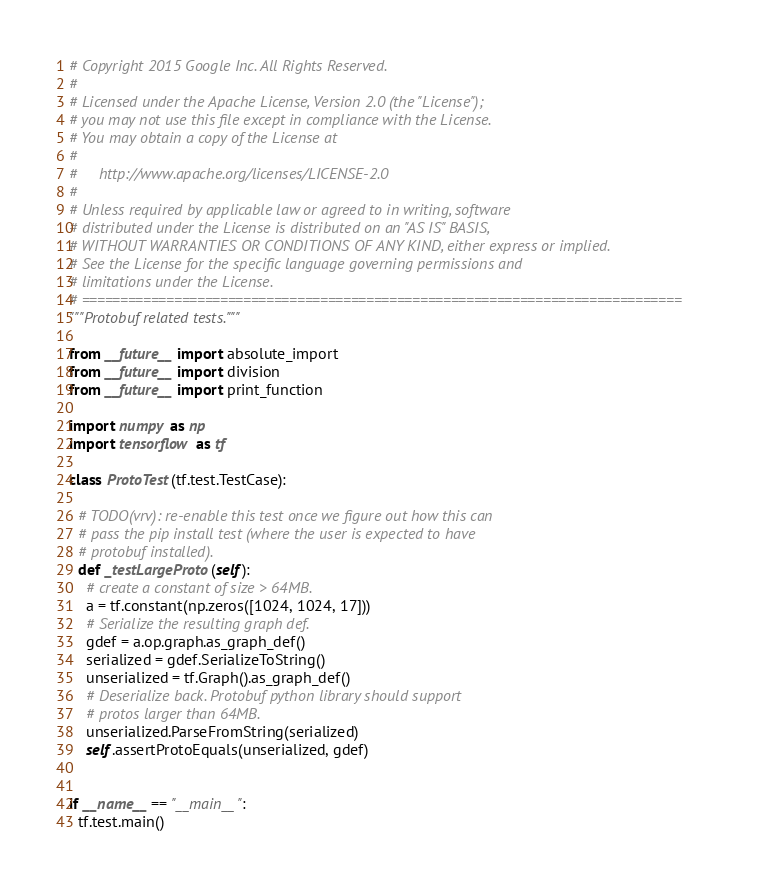<code> <loc_0><loc_0><loc_500><loc_500><_Python_># Copyright 2015 Google Inc. All Rights Reserved.
#
# Licensed under the Apache License, Version 2.0 (the "License");
# you may not use this file except in compliance with the License.
# You may obtain a copy of the License at
#
#     http://www.apache.org/licenses/LICENSE-2.0
#
# Unless required by applicable law or agreed to in writing, software
# distributed under the License is distributed on an "AS IS" BASIS,
# WITHOUT WARRANTIES OR CONDITIONS OF ANY KIND, either express or implied.
# See the License for the specific language governing permissions and
# limitations under the License.
# ==============================================================================
"""Protobuf related tests."""

from __future__ import absolute_import
from __future__ import division
from __future__ import print_function

import numpy as np
import tensorflow as tf

class ProtoTest(tf.test.TestCase):

  # TODO(vrv): re-enable this test once we figure out how this can
  # pass the pip install test (where the user is expected to have
  # protobuf installed).
  def _testLargeProto(self):
    # create a constant of size > 64MB.
    a = tf.constant(np.zeros([1024, 1024, 17]))
    # Serialize the resulting graph def.
    gdef = a.op.graph.as_graph_def()
    serialized = gdef.SerializeToString()
    unserialized = tf.Graph().as_graph_def()
    # Deserialize back. Protobuf python library should support
    # protos larger than 64MB.
    unserialized.ParseFromString(serialized)
    self.assertProtoEquals(unserialized, gdef)


if __name__ == "__main__":
  tf.test.main()
</code> 